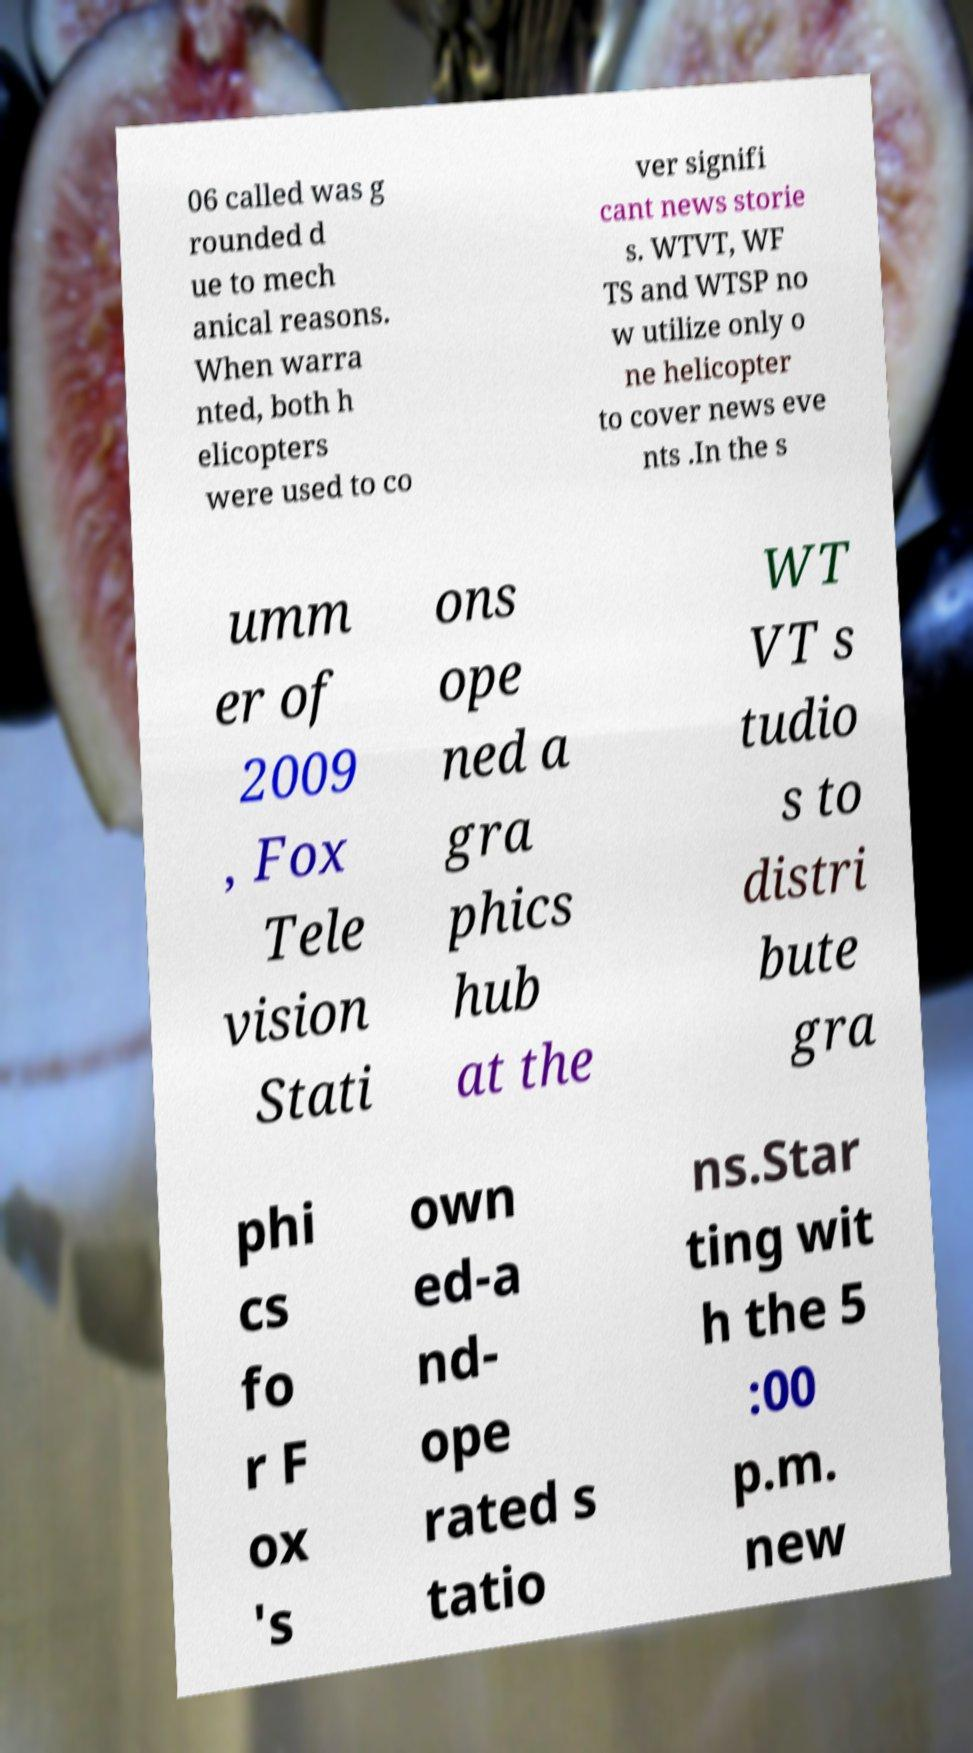Can you read and provide the text displayed in the image?This photo seems to have some interesting text. Can you extract and type it out for me? 06 called was g rounded d ue to mech anical reasons. When warra nted, both h elicopters were used to co ver signifi cant news storie s. WTVT, WF TS and WTSP no w utilize only o ne helicopter to cover news eve nts .In the s umm er of 2009 , Fox Tele vision Stati ons ope ned a gra phics hub at the WT VT s tudio s to distri bute gra phi cs fo r F ox 's own ed-a nd- ope rated s tatio ns.Star ting wit h the 5 :00 p.m. new 